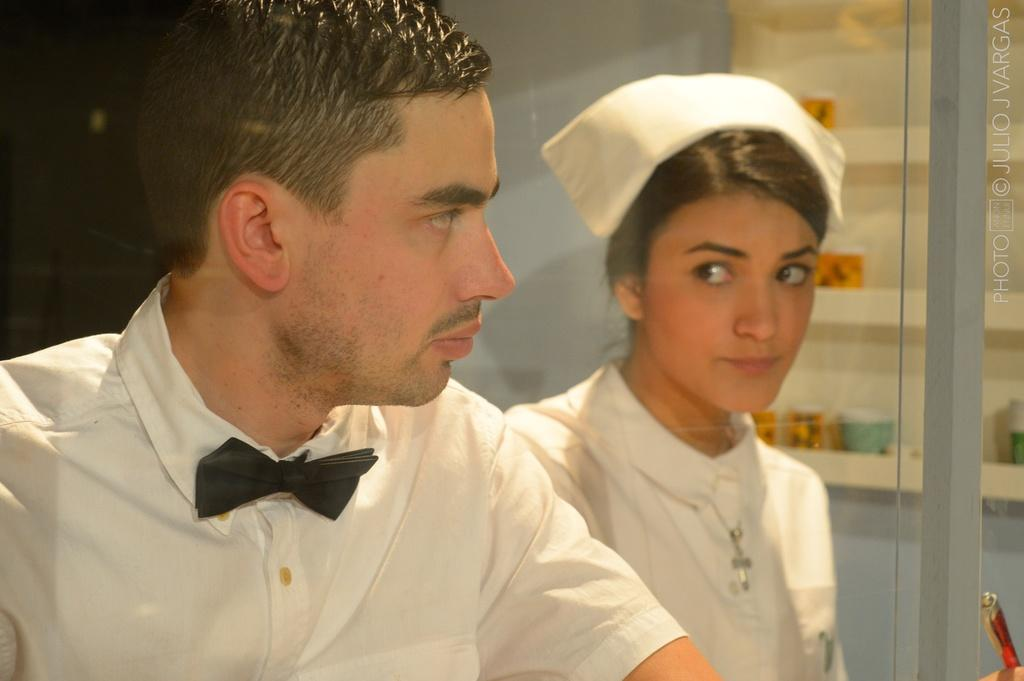Who are the people in the foreground of the image? There is a man and a lady in the foreground of the image. What is the lady holding in the image? The lady appears to be holding a pen. What can be seen in the background of the image? There is a glass door and other objects visible in the background of the image. Where is the text located in the image? The text is visible on the right side of the image. How does the dust settle on the man's face in the image? There is no dust present in the image, so it cannot settle on the man's face. What is the lady adding to the equation in the image? There is no equation or addition activity present in the image; the lady is simply holding a pen. 